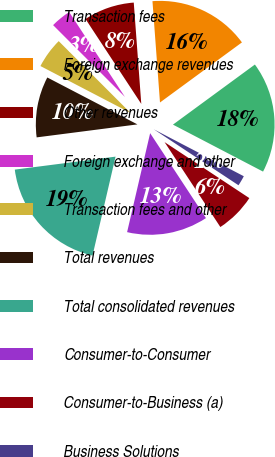Convert chart to OTSL. <chart><loc_0><loc_0><loc_500><loc_500><pie_chart><fcel>Transaction fees<fcel>Foreign exchange revenues<fcel>Other revenues<fcel>Foreign exchange and other<fcel>Transaction fees and other<fcel>Total revenues<fcel>Total consolidated revenues<fcel>Consumer-to-Consumer<fcel>Consumer-to-Business (a)<fcel>Business Solutions<nl><fcel>17.72%<fcel>16.11%<fcel>8.07%<fcel>3.25%<fcel>4.86%<fcel>9.68%<fcel>19.32%<fcel>12.89%<fcel>6.46%<fcel>1.64%<nl></chart> 